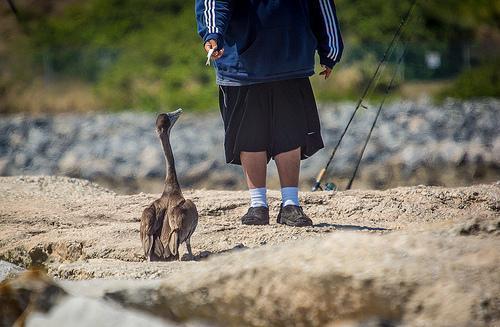How many people on the rocks?
Give a very brief answer. 1. How many fishing poles can be seen?
Give a very brief answer. 2. 